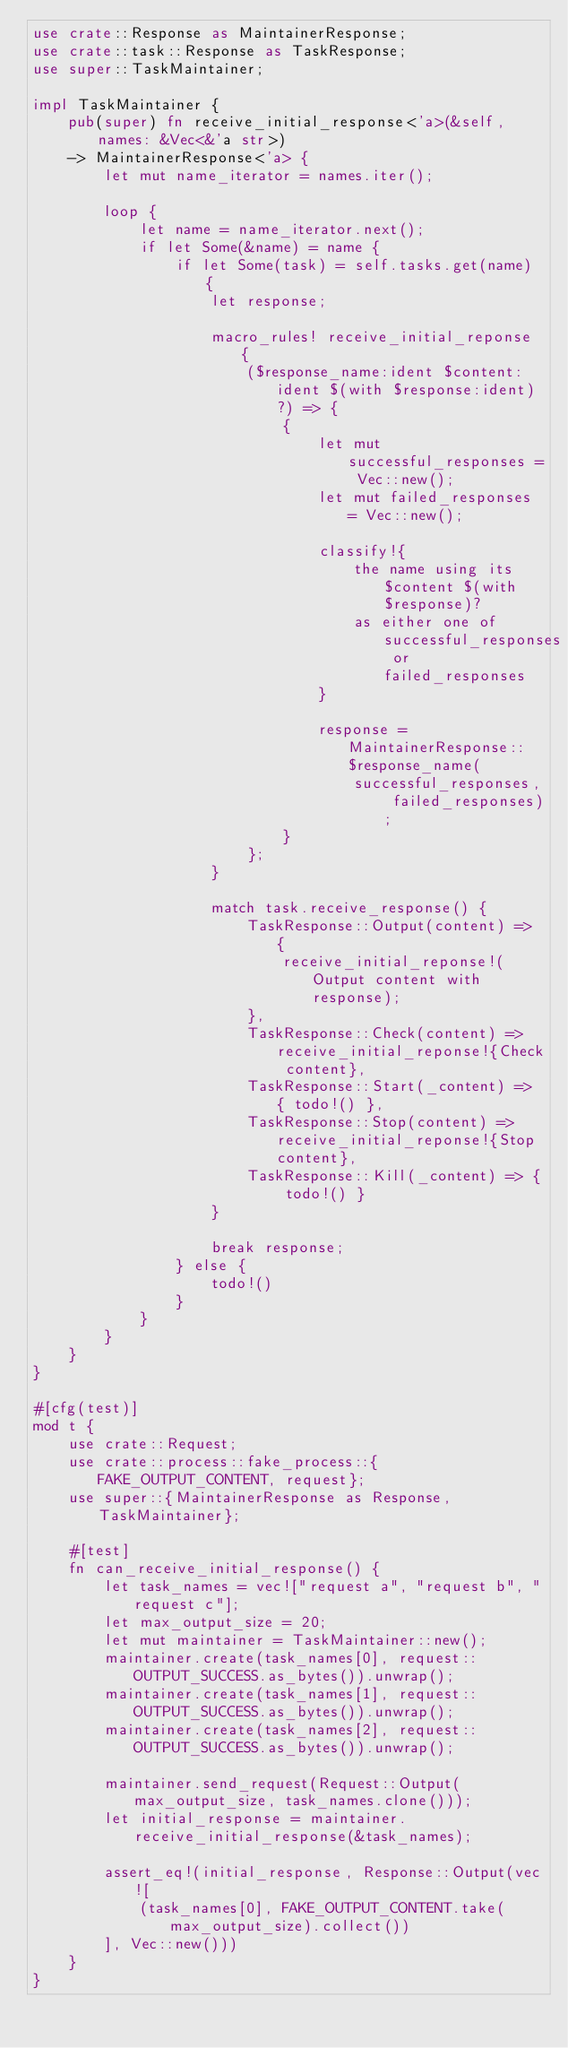Convert code to text. <code><loc_0><loc_0><loc_500><loc_500><_Rust_>use crate::Response as MaintainerResponse;
use crate::task::Response as TaskResponse;
use super::TaskMaintainer;

impl TaskMaintainer {
	pub(super) fn receive_initial_response<'a>(&self, names: &Vec<&'a str>)
	-> MaintainerResponse<'a> {
		let mut name_iterator = names.iter();

		loop {
			let name = name_iterator.next();
			if let Some(&name) = name {
				if let Some(task) = self.tasks.get(name) {
					let response;

					macro_rules! receive_initial_reponse {
						($response_name:ident $content:ident $(with $response:ident)?) => {
							{
								let mut successful_responses = Vec::new();
								let mut failed_responses = Vec::new();

								classify!{
									the name using its $content $(with $response)?
									as either one of successful_responses or failed_responses
								}

								response = MaintainerResponse::$response_name(
									successful_responses, failed_responses);
							}
						};
					}

					match task.receive_response() {
						TaskResponse::Output(content) => {
							receive_initial_reponse!(Output content with response);
						},
						TaskResponse::Check(content) => receive_initial_reponse!{Check content},
						TaskResponse::Start(_content) => { todo!() },
						TaskResponse::Stop(content) => receive_initial_reponse!{Stop content},
						TaskResponse::Kill(_content) => { todo!() }
					}

					break response;
				} else {
					todo!()
				}
			}
		}
	}
}

#[cfg(test)]
mod t {
	use crate::Request;
	use crate::process::fake_process::{FAKE_OUTPUT_CONTENT, request};
	use super::{MaintainerResponse as Response, TaskMaintainer};

	#[test]
	fn can_receive_initial_response() {
		let task_names = vec!["request a", "request b", "request c"];
		let max_output_size = 20;
		let mut maintainer = TaskMaintainer::new();
		maintainer.create(task_names[0], request::OUTPUT_SUCCESS.as_bytes()).unwrap();
		maintainer.create(task_names[1], request::OUTPUT_SUCCESS.as_bytes()).unwrap();
		maintainer.create(task_names[2], request::OUTPUT_SUCCESS.as_bytes()).unwrap();

		maintainer.send_request(Request::Output(max_output_size, task_names.clone()));
		let initial_response = maintainer.receive_initial_response(&task_names);

		assert_eq!(initial_response, Response::Output(vec![
			(task_names[0], FAKE_OUTPUT_CONTENT.take(max_output_size).collect())
		], Vec::new()))
	}
}
</code> 